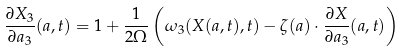Convert formula to latex. <formula><loc_0><loc_0><loc_500><loc_500>\frac { \partial X _ { 3 } } { \partial a _ { 3 } } ( a , t ) = 1 + \frac { 1 } { 2 \Omega } \left ( \omega _ { 3 } ( X ( a , t ) , t ) - \zeta ( a ) \cdot \frac { \partial X } { \partial a _ { 3 } } ( a , t ) \right )</formula> 